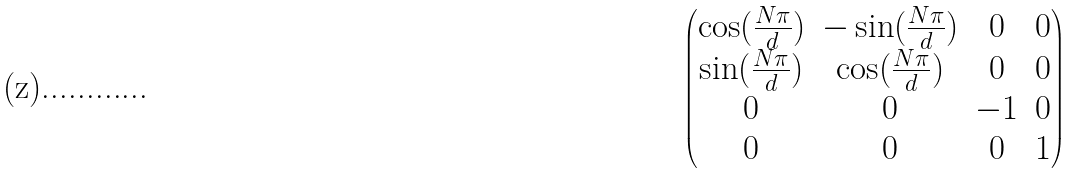Convert formula to latex. <formula><loc_0><loc_0><loc_500><loc_500>\begin{pmatrix} \cos ( \frac { N \pi } { d } ) & - \sin ( \frac { N \pi } { d } ) & 0 & 0 \\ \sin ( \frac { N \pi } { d } ) & \cos ( \frac { N \pi } { d } ) & 0 & 0 \\ 0 & 0 & - 1 & 0 \\ 0 & 0 & 0 & 1 \end{pmatrix}</formula> 